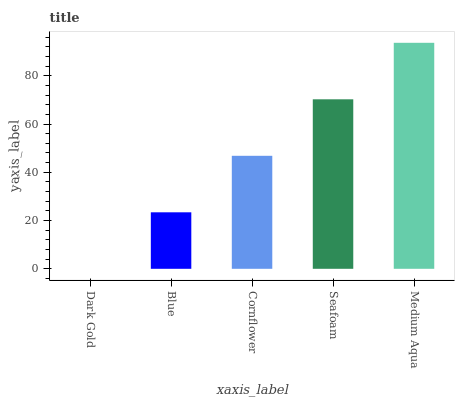Is Dark Gold the minimum?
Answer yes or no. Yes. Is Medium Aqua the maximum?
Answer yes or no. Yes. Is Blue the minimum?
Answer yes or no. No. Is Blue the maximum?
Answer yes or no. No. Is Blue greater than Dark Gold?
Answer yes or no. Yes. Is Dark Gold less than Blue?
Answer yes or no. Yes. Is Dark Gold greater than Blue?
Answer yes or no. No. Is Blue less than Dark Gold?
Answer yes or no. No. Is Cornflower the high median?
Answer yes or no. Yes. Is Cornflower the low median?
Answer yes or no. Yes. Is Seafoam the high median?
Answer yes or no. No. Is Medium Aqua the low median?
Answer yes or no. No. 